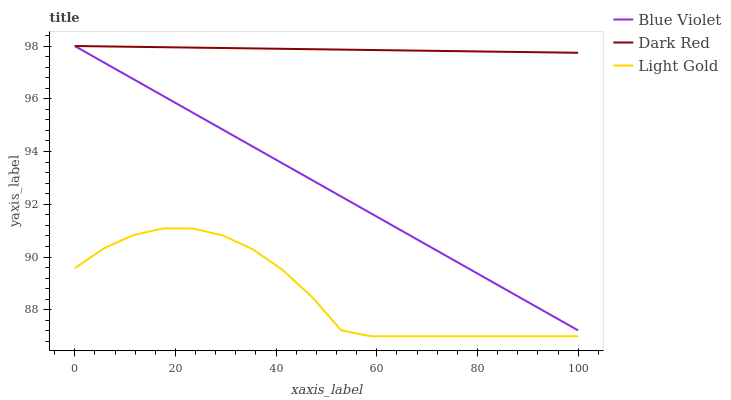Does Light Gold have the minimum area under the curve?
Answer yes or no. Yes. Does Dark Red have the maximum area under the curve?
Answer yes or no. Yes. Does Blue Violet have the minimum area under the curve?
Answer yes or no. No. Does Blue Violet have the maximum area under the curve?
Answer yes or no. No. Is Dark Red the smoothest?
Answer yes or no. Yes. Is Light Gold the roughest?
Answer yes or no. Yes. Is Blue Violet the smoothest?
Answer yes or no. No. Is Blue Violet the roughest?
Answer yes or no. No. Does Blue Violet have the lowest value?
Answer yes or no. No. Does Blue Violet have the highest value?
Answer yes or no. Yes. Does Light Gold have the highest value?
Answer yes or no. No. Is Light Gold less than Blue Violet?
Answer yes or no. Yes. Is Blue Violet greater than Light Gold?
Answer yes or no. Yes. Does Blue Violet intersect Dark Red?
Answer yes or no. Yes. Is Blue Violet less than Dark Red?
Answer yes or no. No. Is Blue Violet greater than Dark Red?
Answer yes or no. No. Does Light Gold intersect Blue Violet?
Answer yes or no. No. 